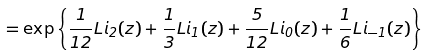Convert formula to latex. <formula><loc_0><loc_0><loc_500><loc_500>= \exp \left \{ \frac { 1 } { 1 2 } L i _ { 2 } ( z ) + \frac { 1 } { 3 } L i _ { 1 } ( z ) + \frac { 5 } { 1 2 } L i _ { 0 } ( z ) + \frac { 1 } { 6 } L i _ { - 1 } ( z ) \right \}</formula> 